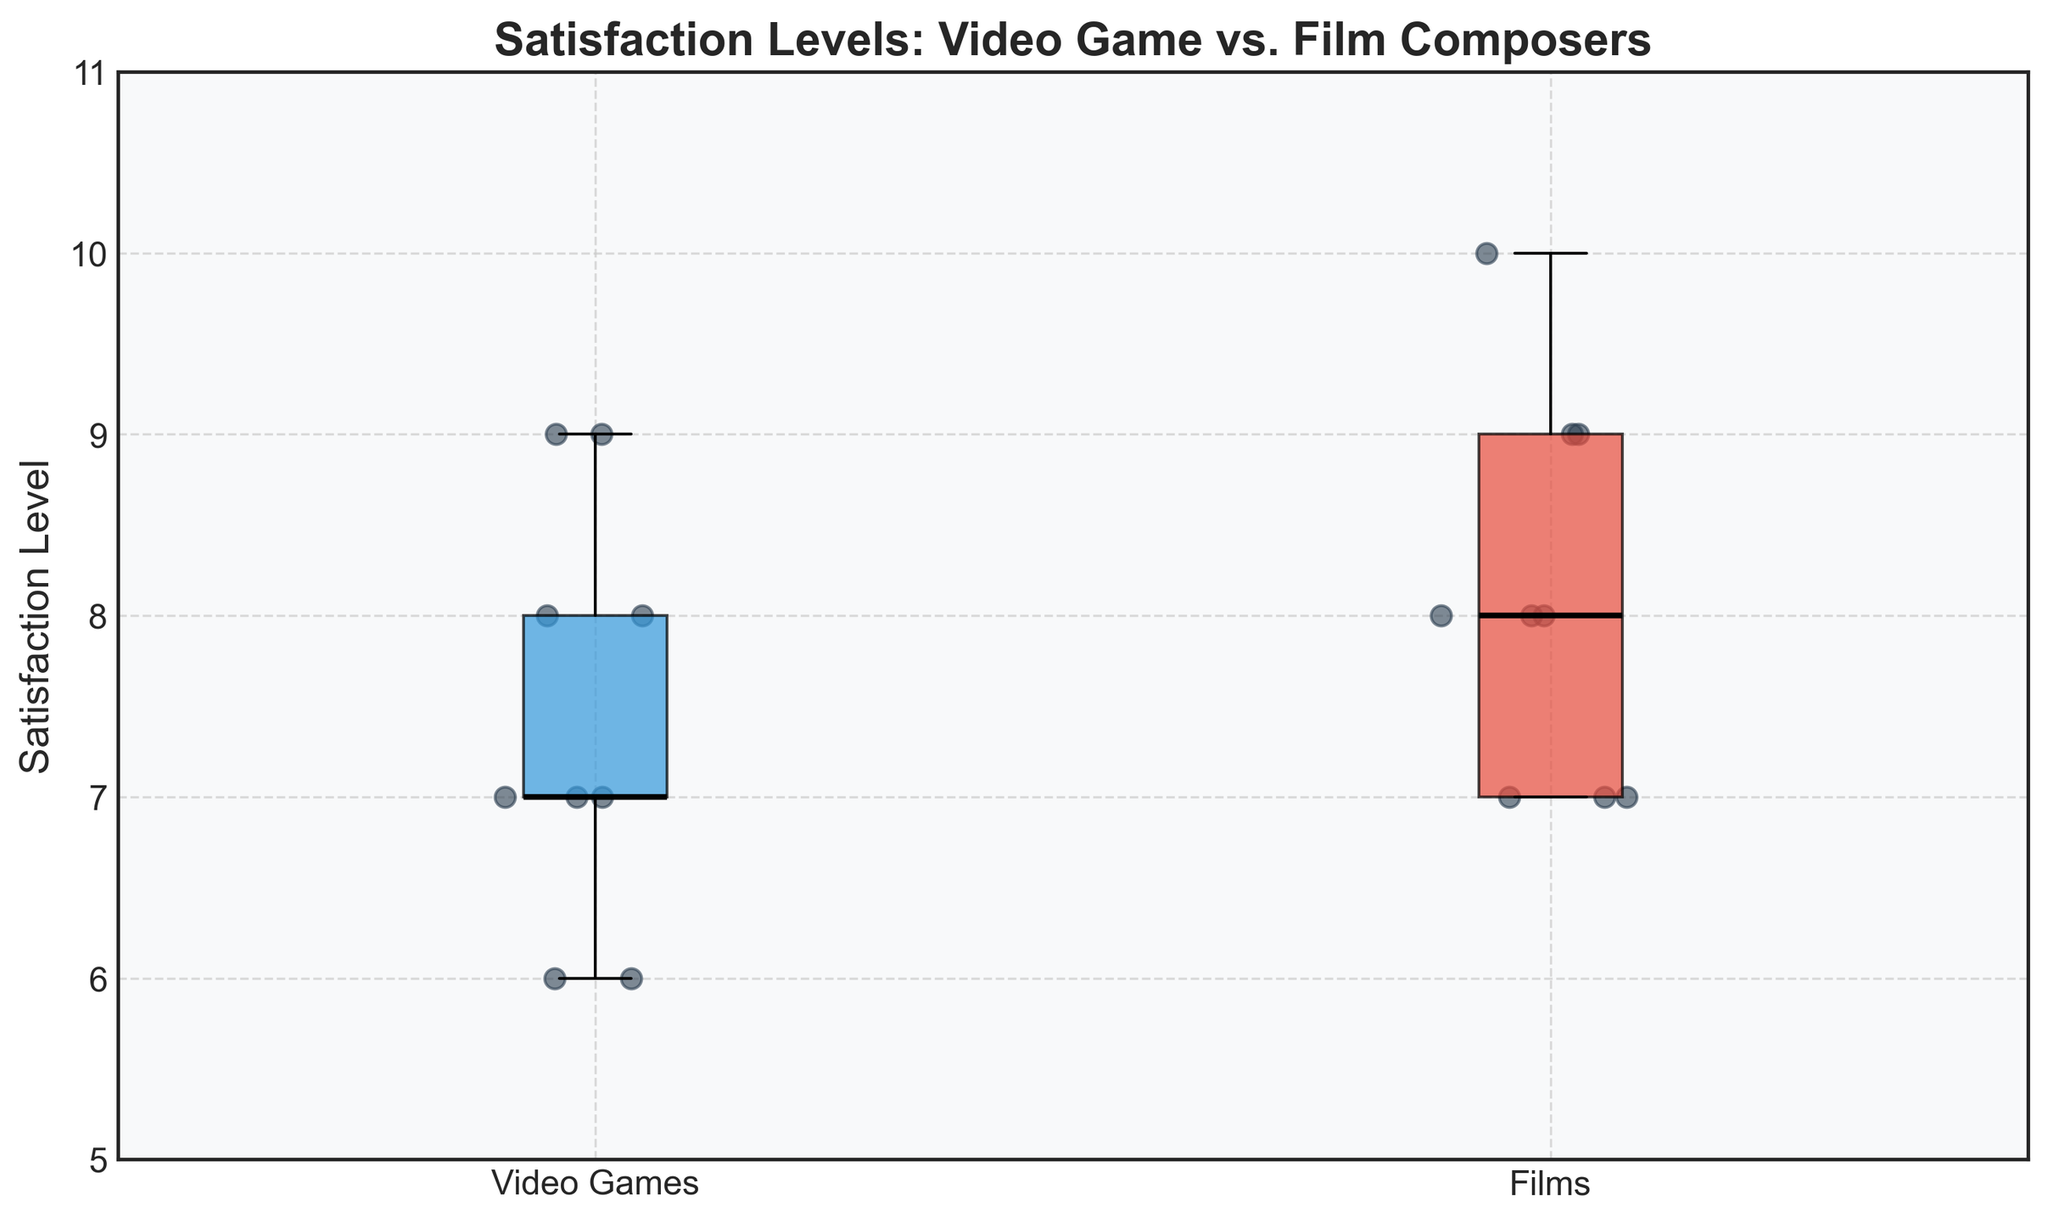What is the title of the plot? The title of the plot is written at the top and can be directly read from the figure.
Answer: Satisfaction Levels: Video Game vs. Film Composers What is the median satisfaction level for video game composers? The median is represented by the black line inside the box of the box plot for video game composers.
Answer: 7.5 Which group has a higher median satisfaction level? Compare the black median lines inside each box for both groups. The median for film composers is higher.
Answer: Films How many satisfaction levels are represented for film composers? Count the individual data points (dots) within the film composers' section of the box plot.
Answer: 9 What are the colors of the boxes for video games and films? The colors of the boxes are distinct and can be directly observed from the figure.
Answer: Blue (Video Games), Red (Films) What is the range of the satisfaction levels for video game composers? The range is the difference between the highest and lowest points in the box plot for video game composers. These points are represented by the ends of the whiskers.
Answer: 6-9 Are there any outliers in the satisfaction levels for either group? Outliers would be represented as individual points outside the whiskers of the box plots in either group. There are no such points in the figure.
Answer: No Who has the lowest satisfaction level among the video game composers, and what is it? The lowest satisfaction level is represented by the bottom end of the whisker in the video game composers' box plot.
Answer: 6 (Yasunori Mitsuda and Akira Yamaoka) Which group has a wider interquartile range (IQR)? The IQR is the range between the 25th percentile (bottom of the box) and the 75th percentile (top of the box). Compare the height of the boxes for both groups.
Answer: Video Games How does the spread of satisfaction levels compare between the two groups? Compare the length of the whiskers and the overall height of the boxes in both groups. The video game composers have a more spread-out distribution.
Answer: Video Games have a wider spread 